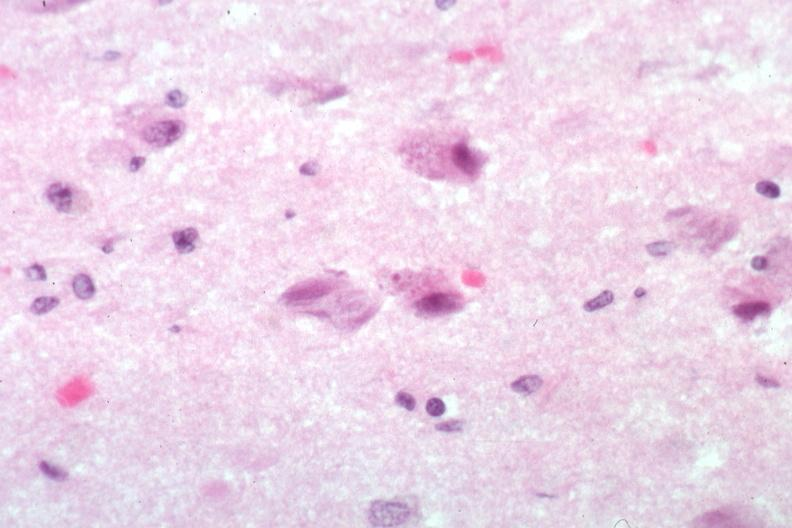s malignant thymoma present?
Answer the question using a single word or phrase. No 